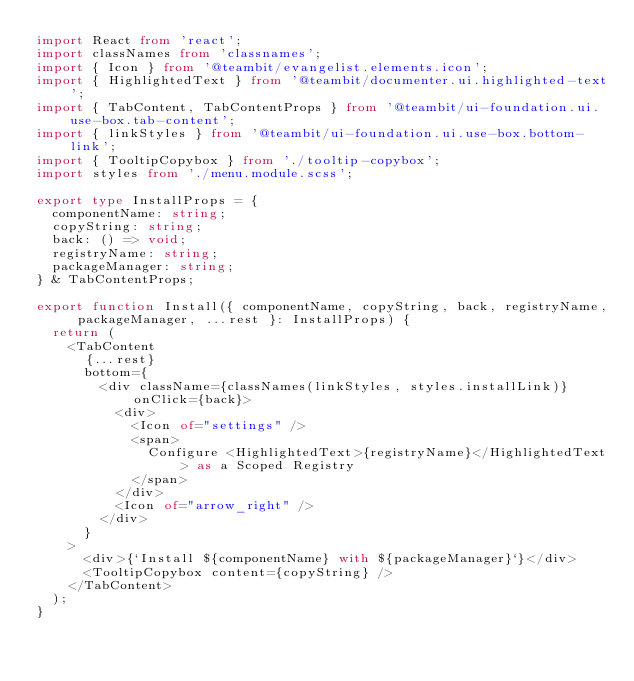Convert code to text. <code><loc_0><loc_0><loc_500><loc_500><_TypeScript_>import React from 'react';
import classNames from 'classnames';
import { Icon } from '@teambit/evangelist.elements.icon';
import { HighlightedText } from '@teambit/documenter.ui.highlighted-text';
import { TabContent, TabContentProps } from '@teambit/ui-foundation.ui.use-box.tab-content';
import { linkStyles } from '@teambit/ui-foundation.ui.use-box.bottom-link';
import { TooltipCopybox } from './tooltip-copybox';
import styles from './menu.module.scss';

export type InstallProps = {
  componentName: string;
  copyString: string;
  back: () => void;
  registryName: string;
  packageManager: string;
} & TabContentProps;

export function Install({ componentName, copyString, back, registryName, packageManager, ...rest }: InstallProps) {
  return (
    <TabContent
      {...rest}
      bottom={
        <div className={classNames(linkStyles, styles.installLink)} onClick={back}>
          <div>
            <Icon of="settings" />
            <span>
              Configure <HighlightedText>{registryName}</HighlightedText> as a Scoped Registry
            </span>
          </div>
          <Icon of="arrow_right" />
        </div>
      }
    >
      <div>{`Install ${componentName} with ${packageManager}`}</div>
      <TooltipCopybox content={copyString} />
    </TabContent>
  );
}
</code> 